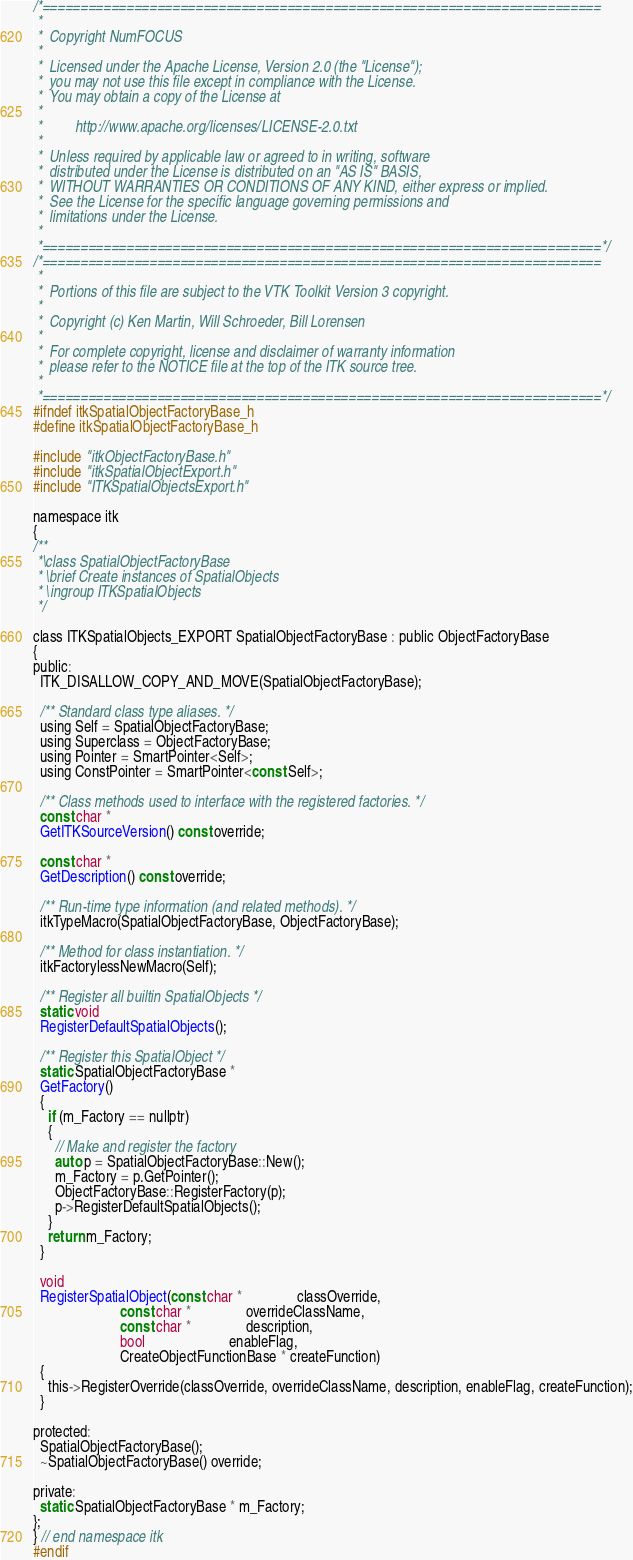Convert code to text. <code><loc_0><loc_0><loc_500><loc_500><_C_>/*=========================================================================
 *
 *  Copyright NumFOCUS
 *
 *  Licensed under the Apache License, Version 2.0 (the "License");
 *  you may not use this file except in compliance with the License.
 *  You may obtain a copy of the License at
 *
 *         http://www.apache.org/licenses/LICENSE-2.0.txt
 *
 *  Unless required by applicable law or agreed to in writing, software
 *  distributed under the License is distributed on an "AS IS" BASIS,
 *  WITHOUT WARRANTIES OR CONDITIONS OF ANY KIND, either express or implied.
 *  See the License for the specific language governing permissions and
 *  limitations under the License.
 *
 *=========================================================================*/
/*=========================================================================
 *
 *  Portions of this file are subject to the VTK Toolkit Version 3 copyright.
 *
 *  Copyright (c) Ken Martin, Will Schroeder, Bill Lorensen
 *
 *  For complete copyright, license and disclaimer of warranty information
 *  please refer to the NOTICE file at the top of the ITK source tree.
 *
 *=========================================================================*/
#ifndef itkSpatialObjectFactoryBase_h
#define itkSpatialObjectFactoryBase_h

#include "itkObjectFactoryBase.h"
#include "itkSpatialObjectExport.h"
#include "ITKSpatialObjectsExport.h"

namespace itk
{
/**
 *\class SpatialObjectFactoryBase
 * \brief Create instances of SpatialObjects
 * \ingroup ITKSpatialObjects
 */

class ITKSpatialObjects_EXPORT SpatialObjectFactoryBase : public ObjectFactoryBase
{
public:
  ITK_DISALLOW_COPY_AND_MOVE(SpatialObjectFactoryBase);

  /** Standard class type aliases. */
  using Self = SpatialObjectFactoryBase;
  using Superclass = ObjectFactoryBase;
  using Pointer = SmartPointer<Self>;
  using ConstPointer = SmartPointer<const Self>;

  /** Class methods used to interface with the registered factories. */
  const char *
  GetITKSourceVersion() const override;

  const char *
  GetDescription() const override;

  /** Run-time type information (and related methods). */
  itkTypeMacro(SpatialObjectFactoryBase, ObjectFactoryBase);

  /** Method for class instantiation. */
  itkFactorylessNewMacro(Self);

  /** Register all builtin SpatialObjects */
  static void
  RegisterDefaultSpatialObjects();

  /** Register this SpatialObject */
  static SpatialObjectFactoryBase *
  GetFactory()
  {
    if (m_Factory == nullptr)
    {
      // Make and register the factory
      auto p = SpatialObjectFactoryBase::New();
      m_Factory = p.GetPointer();
      ObjectFactoryBase::RegisterFactory(p);
      p->RegisterDefaultSpatialObjects();
    }
    return m_Factory;
  }

  void
  RegisterSpatialObject(const char *               classOverride,
                        const char *               overrideClassName,
                        const char *               description,
                        bool                       enableFlag,
                        CreateObjectFunctionBase * createFunction)
  {
    this->RegisterOverride(classOverride, overrideClassName, description, enableFlag, createFunction);
  }

protected:
  SpatialObjectFactoryBase();
  ~SpatialObjectFactoryBase() override;

private:
  static SpatialObjectFactoryBase * m_Factory;
};
} // end namespace itk
#endif
</code> 